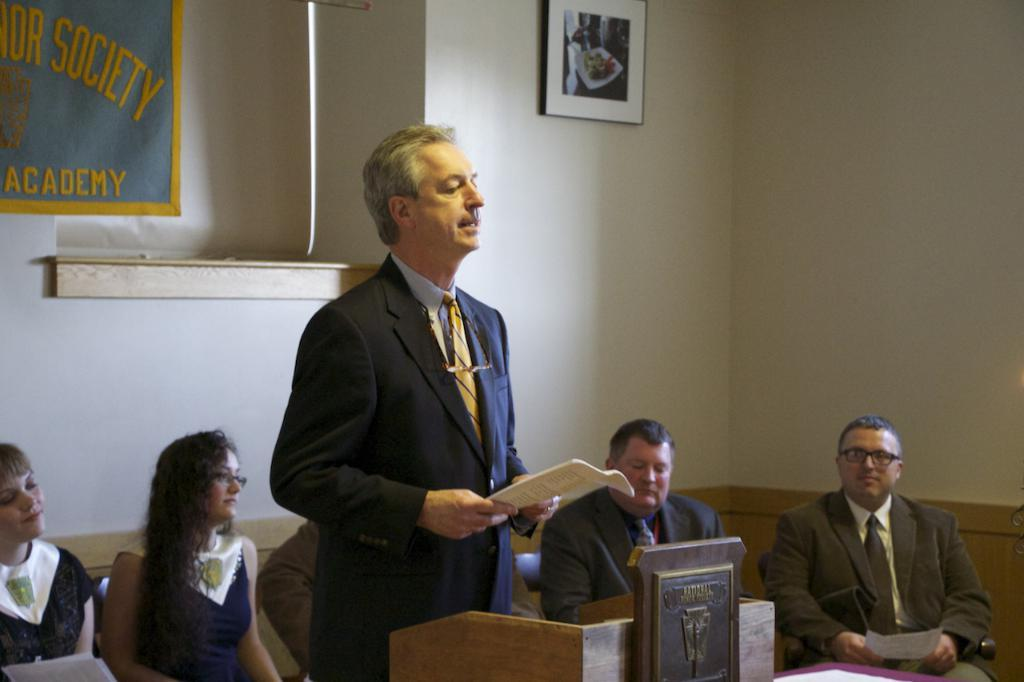What is the person in the image wearing? The person is wearing a suit in the image. What is the person doing in the image? The person is standing in the image. What object is the person holding in their hand? The person is holding a book in their hand. What can be seen in front of the person? There is a wooden stand in front of the person. What is happening behind the person? There are people sitting behind the person. What type of corn is being grown on the person's head in the image? There is no corn present in the image, and the person's head is not shown to be growing any corn. 